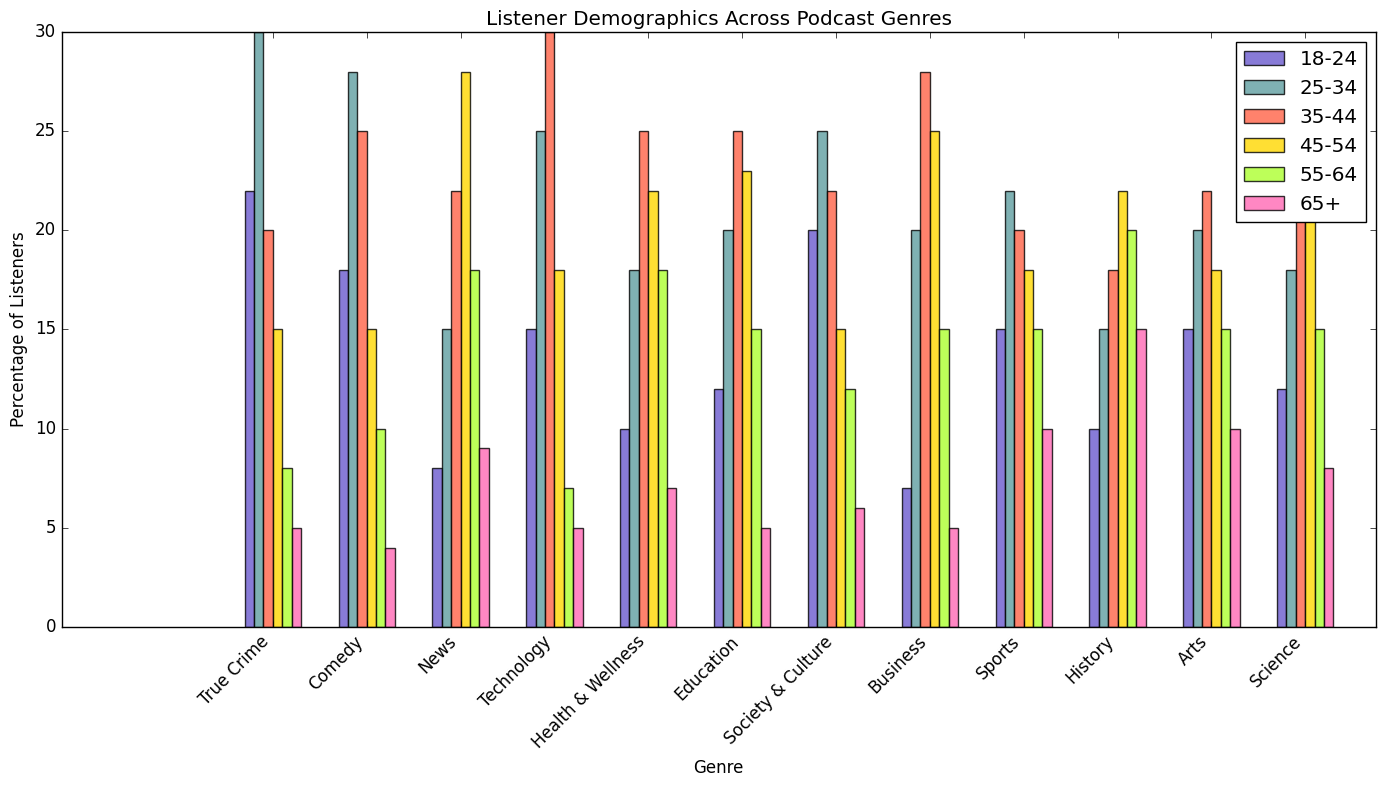Which genre has the highest percentage of 35-44 age group listeners? Look at the bars representing the 35-44 age group for each genre. The tallest bar is for Technology with 30%.
Answer: Technology What's the difference in percentage between 25-34 and 35-44 age groups for the Comedy genre? The bar heights for Comedy show that 25-34 has 28% and 35-44 has 25%. The difference is 28 - 25 = 3%.
Answer: 3% Which genre has the smallest percentage of listeners aged 65 and above? Compare the bars for the 65+ age group across all genres. The shortest bar belongs to Comedy with 4%.
Answer: Comedy Which two genres have the same percentage of listeners aged 55-64? Observe the bars for the 55-64 age group. News and Arts both have a 15% bar height.
Answer: News and Arts In the 18-24 age group, what is the average percentage of listeners across all genres? Add the percentages for 18-24 from all genres: 22+18+8+15+10+12+20+7+15+10+15+12 = 164. There are 12 genres, so 164/12 = ~13.67%.
Answer: ~13.67% Which genre has the highest sum of listeners aged 18-24 and 25-34? For each genre, sum up the percentages for the 18-24 and 25-34 age groups. True Crime has 22+30=52, Comedy has 18+28=46, and Technology has 15+25=40, among others. The highest is True Crime with 52%.
Answer: True Crime In the News genre, is the percentage of listeners aged 25-34 greater than the sum of those aged 45-54 and 65+? The percentage of 25-34 in News is 15%. Sum up the percentages of 45-54 and 65+ which are 28 and 9 respectively, giving a total of 37%. 15% is not greater than 37%.
Answer: No Which genres have more than 20% of listeners in both the 35-44 and 45-54 age groups? Look at the bars for 35-44 and 45-54 age groups. Technology, Health & Wellness, Education, Business, and Science all have more than 20% for both age groups.
Answer: Technology, Health & Wellness, Education, Business, and Science Compare Society & Culture with Business for the age group 45-54. Which genre has a higher percentage of listeners? Look at the bars for the 45-54 age group in Society & Culture and Business. Society & Culture has 15% and Business has 25%. So, Business has a higher percentage.
Answer: Business 